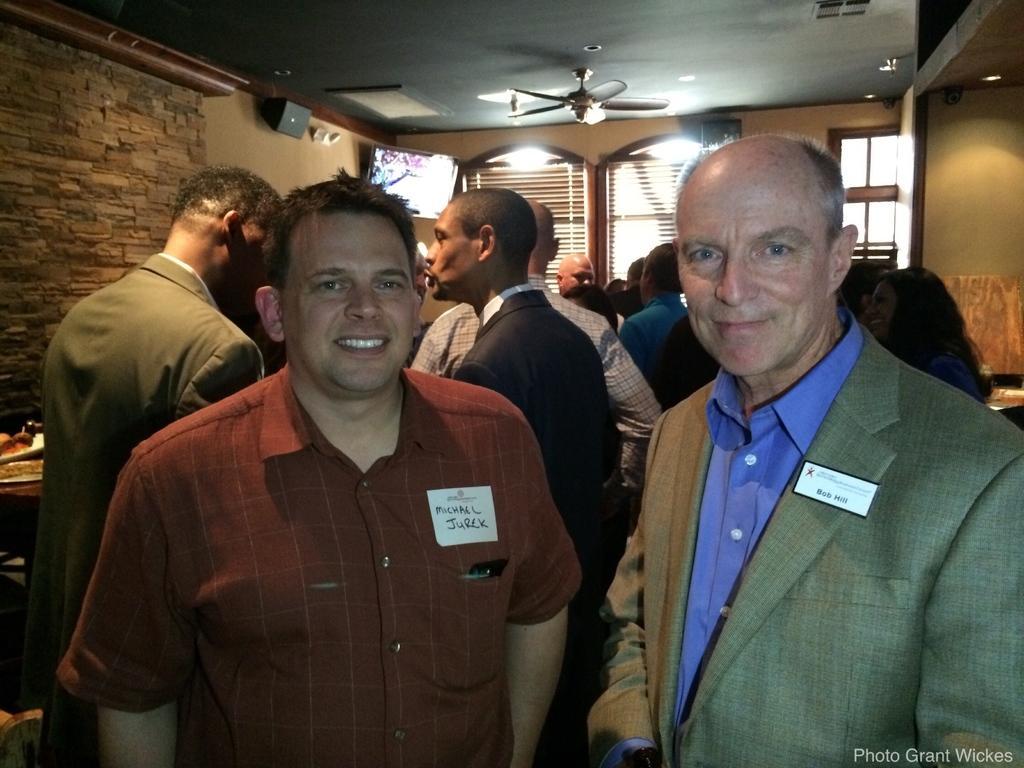Describe this image in one or two sentences. This image is taken indoors. In the background there is a wall with a window and a door. There are two window blinds. At the top of the image there is a ceiling and there is a fan. In the middle of the image a few people are standing on the floor and talking. Two men are standing and they are with smiling faces. On the left side of the image there is a table with a few things on it. 